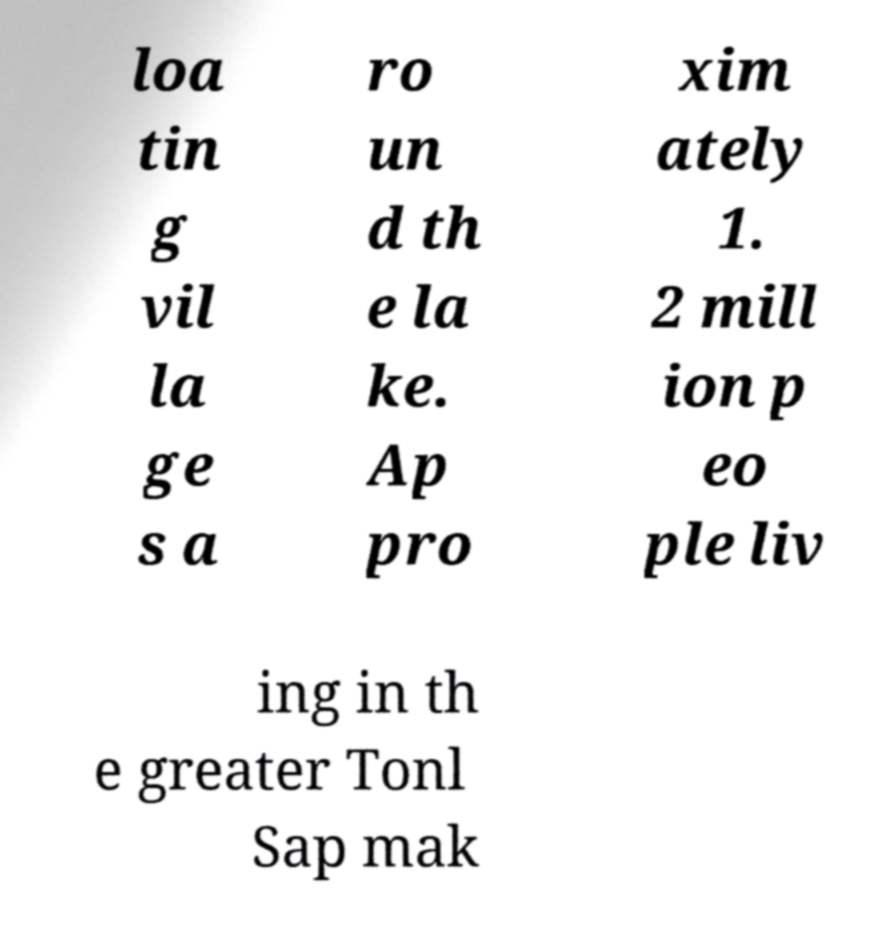Can you read and provide the text displayed in the image?This photo seems to have some interesting text. Can you extract and type it out for me? loa tin g vil la ge s a ro un d th e la ke. Ap pro xim ately 1. 2 mill ion p eo ple liv ing in th e greater Tonl Sap mak 